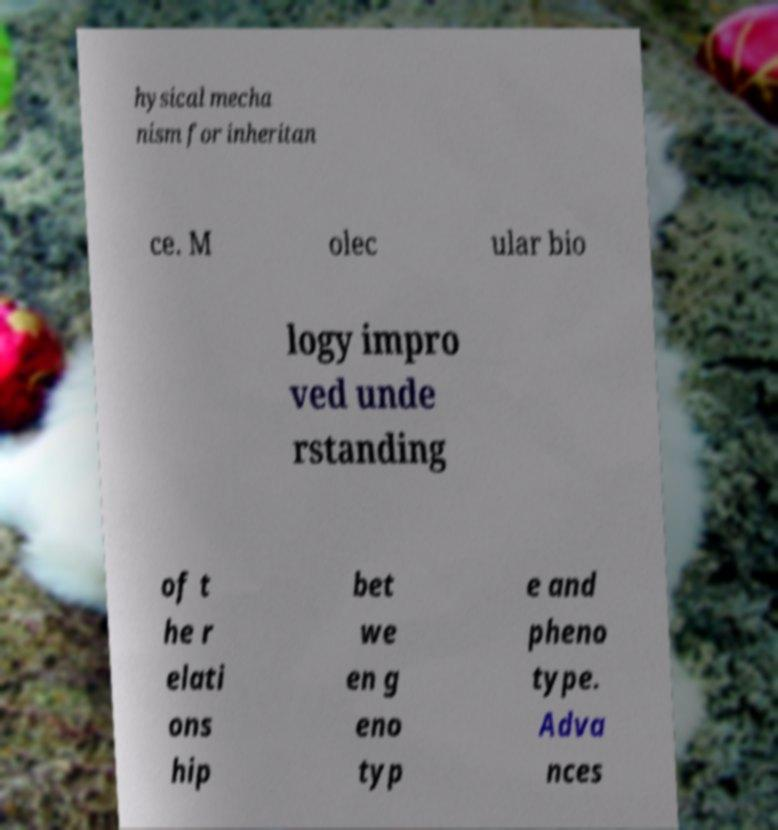Can you accurately transcribe the text from the provided image for me? hysical mecha nism for inheritan ce. M olec ular bio logy impro ved unde rstanding of t he r elati ons hip bet we en g eno typ e and pheno type. Adva nces 